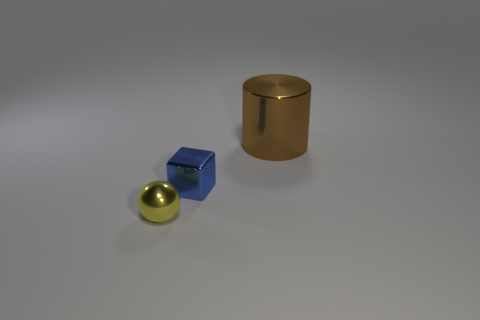Add 3 brown balls. How many objects exist? 6 Subtract all spheres. How many objects are left? 2 Subtract all cyan rubber spheres. Subtract all small blue metallic cubes. How many objects are left? 2 Add 3 small metallic things. How many small metallic things are left? 5 Add 1 small purple shiny cylinders. How many small purple shiny cylinders exist? 1 Subtract 0 green cylinders. How many objects are left? 3 